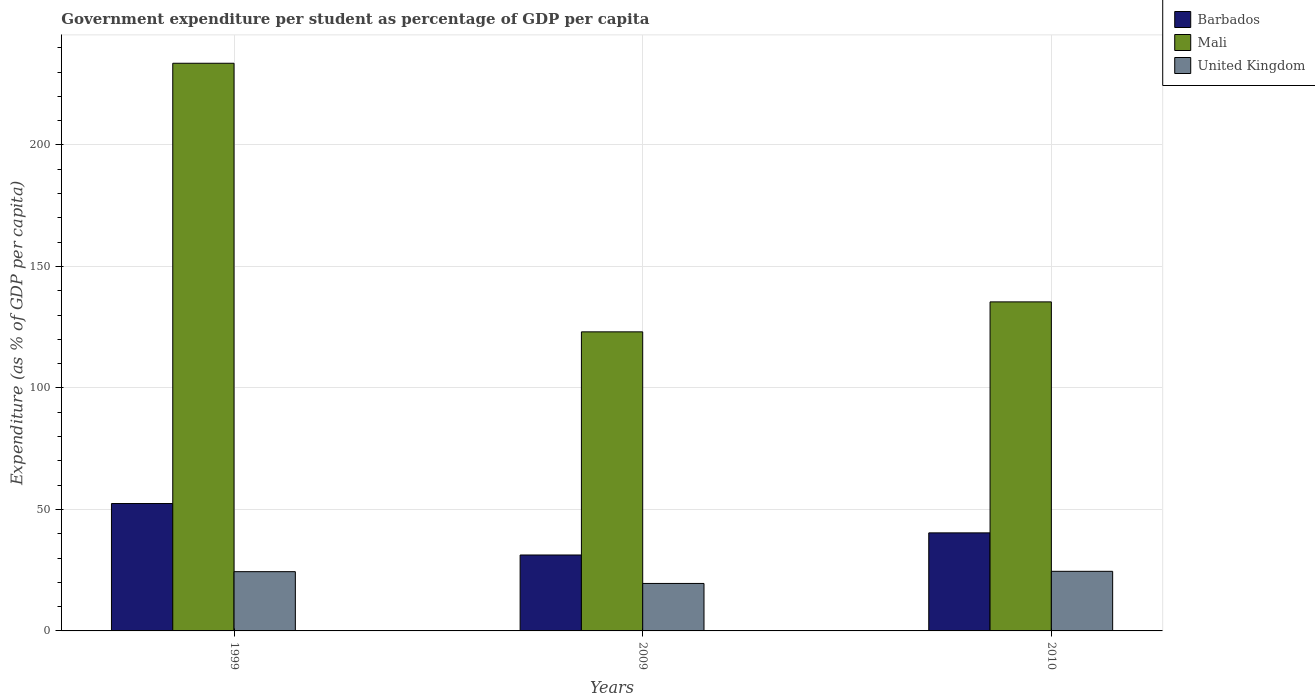Are the number of bars per tick equal to the number of legend labels?
Your answer should be very brief. Yes. What is the label of the 1st group of bars from the left?
Make the answer very short. 1999. What is the percentage of expenditure per student in Mali in 2010?
Your answer should be compact. 135.4. Across all years, what is the maximum percentage of expenditure per student in Mali?
Ensure brevity in your answer.  233.6. Across all years, what is the minimum percentage of expenditure per student in United Kingdom?
Provide a short and direct response. 19.54. In which year was the percentage of expenditure per student in Barbados maximum?
Ensure brevity in your answer.  1999. What is the total percentage of expenditure per student in Barbados in the graph?
Offer a terse response. 124.02. What is the difference between the percentage of expenditure per student in Barbados in 2009 and that in 2010?
Give a very brief answer. -9.11. What is the difference between the percentage of expenditure per student in United Kingdom in 2010 and the percentage of expenditure per student in Barbados in 1999?
Your response must be concise. -27.9. What is the average percentage of expenditure per student in Barbados per year?
Offer a very short reply. 41.34. In the year 2009, what is the difference between the percentage of expenditure per student in Mali and percentage of expenditure per student in Barbados?
Ensure brevity in your answer.  91.83. What is the ratio of the percentage of expenditure per student in Barbados in 1999 to that in 2010?
Make the answer very short. 1.3. Is the percentage of expenditure per student in United Kingdom in 1999 less than that in 2010?
Ensure brevity in your answer.  Yes. Is the difference between the percentage of expenditure per student in Mali in 1999 and 2010 greater than the difference between the percentage of expenditure per student in Barbados in 1999 and 2010?
Keep it short and to the point. Yes. What is the difference between the highest and the second highest percentage of expenditure per student in Mali?
Provide a succinct answer. 98.2. What is the difference between the highest and the lowest percentage of expenditure per student in Mali?
Ensure brevity in your answer.  110.53. Is the sum of the percentage of expenditure per student in Mali in 2009 and 2010 greater than the maximum percentage of expenditure per student in United Kingdom across all years?
Make the answer very short. Yes. What does the 3rd bar from the left in 2010 represents?
Your answer should be very brief. United Kingdom. What does the 2nd bar from the right in 2010 represents?
Your response must be concise. Mali. How many bars are there?
Make the answer very short. 9. Are all the bars in the graph horizontal?
Provide a succinct answer. No. Does the graph contain any zero values?
Make the answer very short. No. Does the graph contain grids?
Provide a short and direct response. Yes. What is the title of the graph?
Keep it short and to the point. Government expenditure per student as percentage of GDP per capita. What is the label or title of the Y-axis?
Ensure brevity in your answer.  Expenditure (as % of GDP per capita). What is the Expenditure (as % of GDP per capita) of Barbados in 1999?
Keep it short and to the point. 52.43. What is the Expenditure (as % of GDP per capita) of Mali in 1999?
Provide a succinct answer. 233.6. What is the Expenditure (as % of GDP per capita) in United Kingdom in 1999?
Your answer should be compact. 24.38. What is the Expenditure (as % of GDP per capita) in Barbados in 2009?
Keep it short and to the point. 31.24. What is the Expenditure (as % of GDP per capita) in Mali in 2009?
Keep it short and to the point. 123.07. What is the Expenditure (as % of GDP per capita) of United Kingdom in 2009?
Give a very brief answer. 19.54. What is the Expenditure (as % of GDP per capita) in Barbados in 2010?
Offer a very short reply. 40.35. What is the Expenditure (as % of GDP per capita) in Mali in 2010?
Give a very brief answer. 135.4. What is the Expenditure (as % of GDP per capita) of United Kingdom in 2010?
Your response must be concise. 24.52. Across all years, what is the maximum Expenditure (as % of GDP per capita) in Barbados?
Your answer should be very brief. 52.43. Across all years, what is the maximum Expenditure (as % of GDP per capita) in Mali?
Make the answer very short. 233.6. Across all years, what is the maximum Expenditure (as % of GDP per capita) of United Kingdom?
Your response must be concise. 24.52. Across all years, what is the minimum Expenditure (as % of GDP per capita) of Barbados?
Your response must be concise. 31.24. Across all years, what is the minimum Expenditure (as % of GDP per capita) in Mali?
Provide a short and direct response. 123.07. Across all years, what is the minimum Expenditure (as % of GDP per capita) of United Kingdom?
Provide a succinct answer. 19.54. What is the total Expenditure (as % of GDP per capita) in Barbados in the graph?
Keep it short and to the point. 124.02. What is the total Expenditure (as % of GDP per capita) of Mali in the graph?
Keep it short and to the point. 492.08. What is the total Expenditure (as % of GDP per capita) of United Kingdom in the graph?
Your response must be concise. 68.44. What is the difference between the Expenditure (as % of GDP per capita) in Barbados in 1999 and that in 2009?
Offer a terse response. 21.18. What is the difference between the Expenditure (as % of GDP per capita) of Mali in 1999 and that in 2009?
Your answer should be compact. 110.53. What is the difference between the Expenditure (as % of GDP per capita) in United Kingdom in 1999 and that in 2009?
Make the answer very short. 4.85. What is the difference between the Expenditure (as % of GDP per capita) of Barbados in 1999 and that in 2010?
Give a very brief answer. 12.08. What is the difference between the Expenditure (as % of GDP per capita) in Mali in 1999 and that in 2010?
Offer a very short reply. 98.2. What is the difference between the Expenditure (as % of GDP per capita) of United Kingdom in 1999 and that in 2010?
Make the answer very short. -0.14. What is the difference between the Expenditure (as % of GDP per capita) in Barbados in 2009 and that in 2010?
Ensure brevity in your answer.  -9.11. What is the difference between the Expenditure (as % of GDP per capita) of Mali in 2009 and that in 2010?
Offer a terse response. -12.33. What is the difference between the Expenditure (as % of GDP per capita) in United Kingdom in 2009 and that in 2010?
Offer a terse response. -4.99. What is the difference between the Expenditure (as % of GDP per capita) in Barbados in 1999 and the Expenditure (as % of GDP per capita) in Mali in 2009?
Your answer should be compact. -70.65. What is the difference between the Expenditure (as % of GDP per capita) of Barbados in 1999 and the Expenditure (as % of GDP per capita) of United Kingdom in 2009?
Provide a succinct answer. 32.89. What is the difference between the Expenditure (as % of GDP per capita) of Mali in 1999 and the Expenditure (as % of GDP per capita) of United Kingdom in 2009?
Provide a short and direct response. 214.06. What is the difference between the Expenditure (as % of GDP per capita) of Barbados in 1999 and the Expenditure (as % of GDP per capita) of Mali in 2010?
Make the answer very short. -82.98. What is the difference between the Expenditure (as % of GDP per capita) in Barbados in 1999 and the Expenditure (as % of GDP per capita) in United Kingdom in 2010?
Give a very brief answer. 27.9. What is the difference between the Expenditure (as % of GDP per capita) of Mali in 1999 and the Expenditure (as % of GDP per capita) of United Kingdom in 2010?
Offer a very short reply. 209.08. What is the difference between the Expenditure (as % of GDP per capita) of Barbados in 2009 and the Expenditure (as % of GDP per capita) of Mali in 2010?
Keep it short and to the point. -104.16. What is the difference between the Expenditure (as % of GDP per capita) of Barbados in 2009 and the Expenditure (as % of GDP per capita) of United Kingdom in 2010?
Offer a very short reply. 6.72. What is the difference between the Expenditure (as % of GDP per capita) in Mali in 2009 and the Expenditure (as % of GDP per capita) in United Kingdom in 2010?
Make the answer very short. 98.55. What is the average Expenditure (as % of GDP per capita) in Barbados per year?
Give a very brief answer. 41.34. What is the average Expenditure (as % of GDP per capita) of Mali per year?
Provide a short and direct response. 164.03. What is the average Expenditure (as % of GDP per capita) in United Kingdom per year?
Give a very brief answer. 22.81. In the year 1999, what is the difference between the Expenditure (as % of GDP per capita) of Barbados and Expenditure (as % of GDP per capita) of Mali?
Provide a short and direct response. -181.17. In the year 1999, what is the difference between the Expenditure (as % of GDP per capita) of Barbados and Expenditure (as % of GDP per capita) of United Kingdom?
Offer a terse response. 28.04. In the year 1999, what is the difference between the Expenditure (as % of GDP per capita) of Mali and Expenditure (as % of GDP per capita) of United Kingdom?
Make the answer very short. 209.22. In the year 2009, what is the difference between the Expenditure (as % of GDP per capita) in Barbados and Expenditure (as % of GDP per capita) in Mali?
Make the answer very short. -91.83. In the year 2009, what is the difference between the Expenditure (as % of GDP per capita) in Barbados and Expenditure (as % of GDP per capita) in United Kingdom?
Ensure brevity in your answer.  11.71. In the year 2009, what is the difference between the Expenditure (as % of GDP per capita) of Mali and Expenditure (as % of GDP per capita) of United Kingdom?
Offer a terse response. 103.54. In the year 2010, what is the difference between the Expenditure (as % of GDP per capita) of Barbados and Expenditure (as % of GDP per capita) of Mali?
Offer a very short reply. -95.06. In the year 2010, what is the difference between the Expenditure (as % of GDP per capita) in Barbados and Expenditure (as % of GDP per capita) in United Kingdom?
Offer a terse response. 15.82. In the year 2010, what is the difference between the Expenditure (as % of GDP per capita) in Mali and Expenditure (as % of GDP per capita) in United Kingdom?
Your answer should be very brief. 110.88. What is the ratio of the Expenditure (as % of GDP per capita) of Barbados in 1999 to that in 2009?
Your answer should be very brief. 1.68. What is the ratio of the Expenditure (as % of GDP per capita) in Mali in 1999 to that in 2009?
Your answer should be compact. 1.9. What is the ratio of the Expenditure (as % of GDP per capita) of United Kingdom in 1999 to that in 2009?
Your response must be concise. 1.25. What is the ratio of the Expenditure (as % of GDP per capita) of Barbados in 1999 to that in 2010?
Your answer should be compact. 1.3. What is the ratio of the Expenditure (as % of GDP per capita) of Mali in 1999 to that in 2010?
Offer a terse response. 1.73. What is the ratio of the Expenditure (as % of GDP per capita) in United Kingdom in 1999 to that in 2010?
Your response must be concise. 0.99. What is the ratio of the Expenditure (as % of GDP per capita) in Barbados in 2009 to that in 2010?
Give a very brief answer. 0.77. What is the ratio of the Expenditure (as % of GDP per capita) in Mali in 2009 to that in 2010?
Provide a short and direct response. 0.91. What is the ratio of the Expenditure (as % of GDP per capita) of United Kingdom in 2009 to that in 2010?
Ensure brevity in your answer.  0.8. What is the difference between the highest and the second highest Expenditure (as % of GDP per capita) of Barbados?
Keep it short and to the point. 12.08. What is the difference between the highest and the second highest Expenditure (as % of GDP per capita) of Mali?
Provide a succinct answer. 98.2. What is the difference between the highest and the second highest Expenditure (as % of GDP per capita) of United Kingdom?
Keep it short and to the point. 0.14. What is the difference between the highest and the lowest Expenditure (as % of GDP per capita) of Barbados?
Ensure brevity in your answer.  21.18. What is the difference between the highest and the lowest Expenditure (as % of GDP per capita) in Mali?
Ensure brevity in your answer.  110.53. What is the difference between the highest and the lowest Expenditure (as % of GDP per capita) of United Kingdom?
Your answer should be compact. 4.99. 